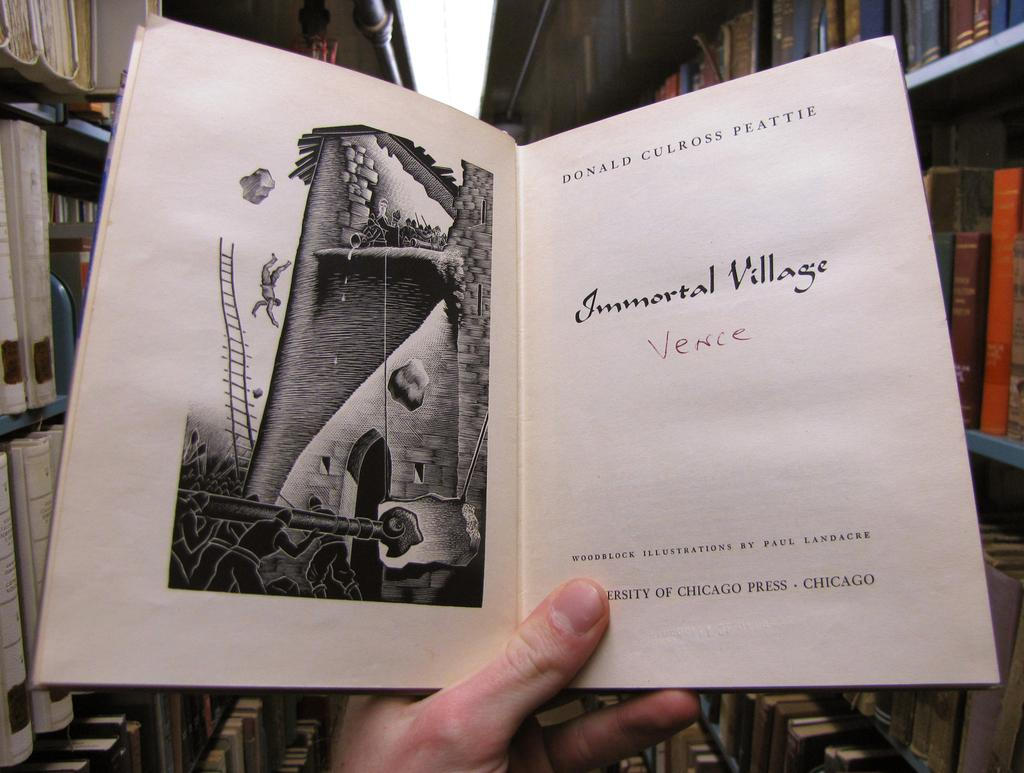<image>
Render a clear and concise summary of the photo. Someone standing in between library shelves is holding an open copy of Immortal Village. 